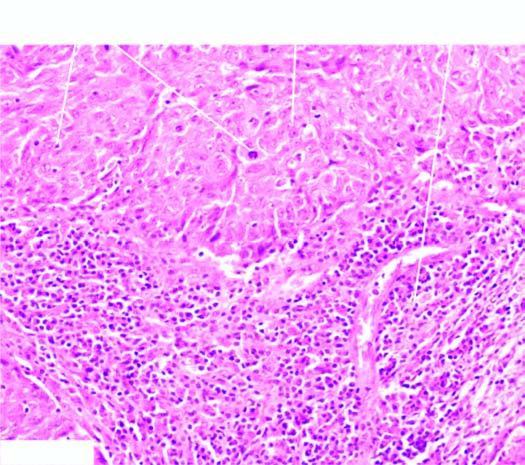what are two characteristic features-large tumour cells forming syncytial arrangement and stroma infiltrated with?
Answer the question using a single word or phrase. Lymphocytes 